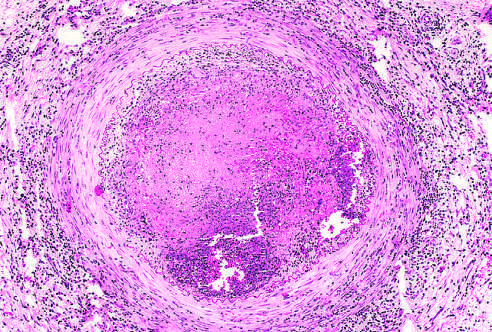what is occluded by thrombus containing a sterile abscess?
Answer the question using a single word or phrase. The lumen 